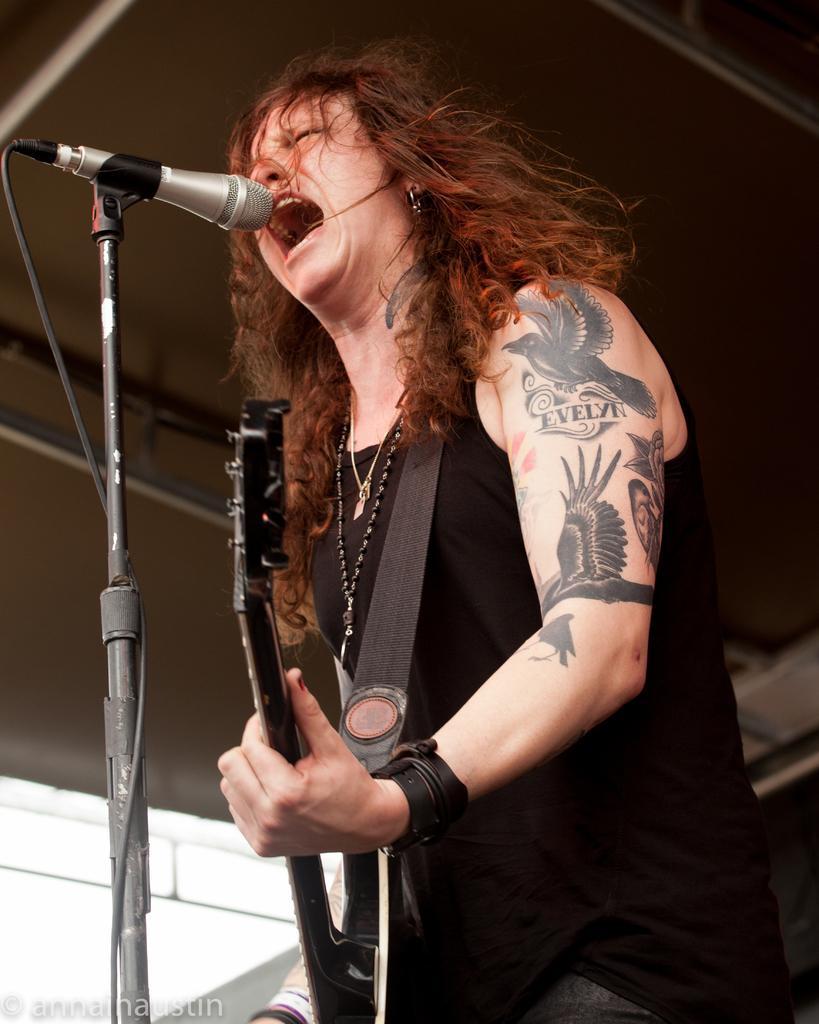Can you describe this image briefly? In this picture there is a woman singing and playing guitar. She is wearing a black dress and has tattoos on her arm. There are bird and text tattoos on her hand. In front of her there is a microphone and its stand. In the above there is roof. To the below left corner of the image there is watermark. 